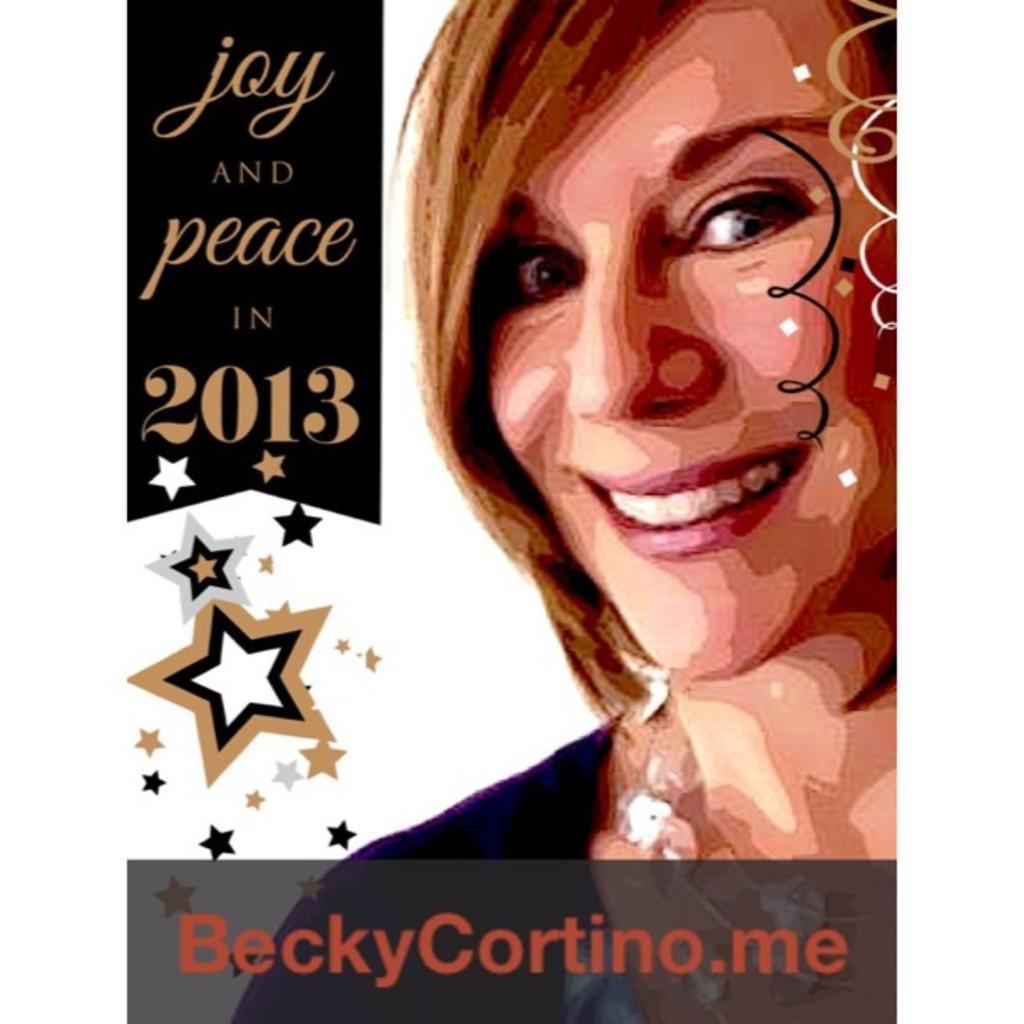Describe this image in one or two sentences. In this image there is a poster as we can see there is a picture a women on the right side of this image. there is some text written on the left side of this image,and there is some text written in the bottom of this image as well. There are some pictures of stars in the bottom left side of this image. 